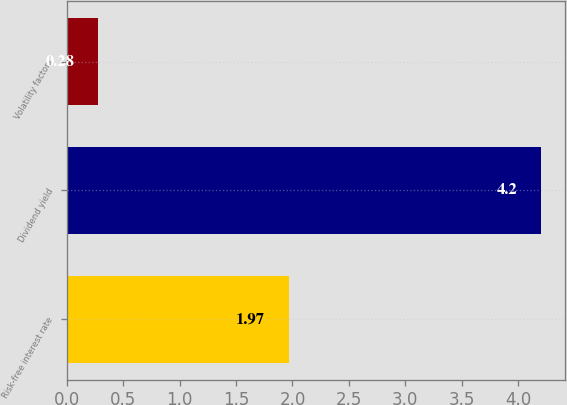Convert chart. <chart><loc_0><loc_0><loc_500><loc_500><bar_chart><fcel>Risk-free interest rate<fcel>Dividend yield<fcel>Volatility factors<nl><fcel>1.97<fcel>4.2<fcel>0.28<nl></chart> 